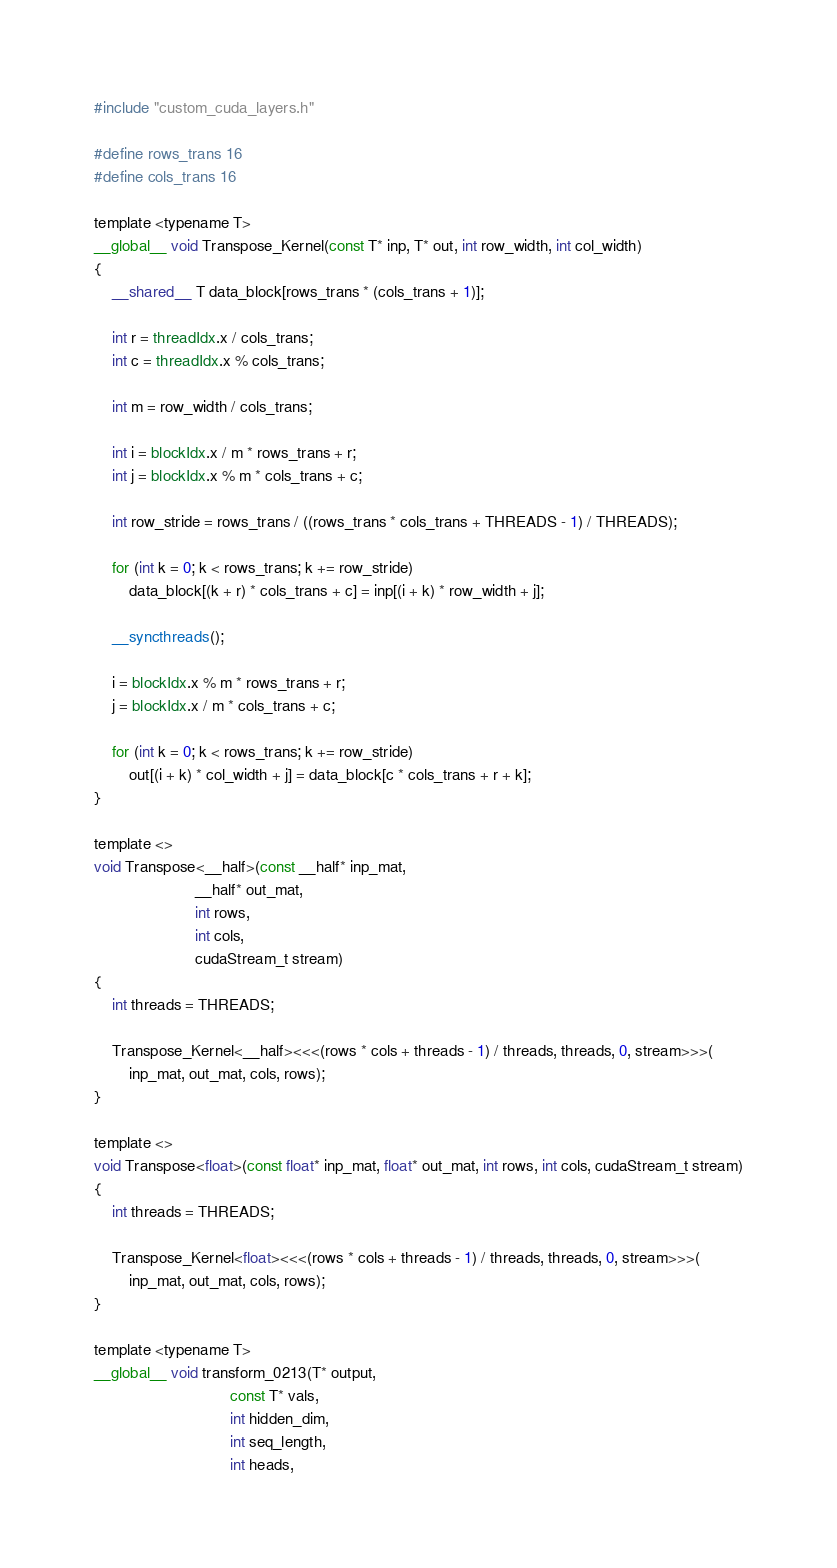<code> <loc_0><loc_0><loc_500><loc_500><_Cuda_>#include "custom_cuda_layers.h"

#define rows_trans 16
#define cols_trans 16

template <typename T>
__global__ void Transpose_Kernel(const T* inp, T* out, int row_width, int col_width)
{
    __shared__ T data_block[rows_trans * (cols_trans + 1)];

    int r = threadIdx.x / cols_trans;
    int c = threadIdx.x % cols_trans;

    int m = row_width / cols_trans;

    int i = blockIdx.x / m * rows_trans + r;
    int j = blockIdx.x % m * cols_trans + c;

    int row_stride = rows_trans / ((rows_trans * cols_trans + THREADS - 1) / THREADS);

    for (int k = 0; k < rows_trans; k += row_stride)
        data_block[(k + r) * cols_trans + c] = inp[(i + k) * row_width + j];

    __syncthreads();

    i = blockIdx.x % m * rows_trans + r;
    j = blockIdx.x / m * cols_trans + c;

    for (int k = 0; k < rows_trans; k += row_stride)
        out[(i + k) * col_width + j] = data_block[c * cols_trans + r + k];
}

template <>
void Transpose<__half>(const __half* inp_mat,
                       __half* out_mat,
                       int rows,
                       int cols,
                       cudaStream_t stream)
{
    int threads = THREADS;

    Transpose_Kernel<__half><<<(rows * cols + threads - 1) / threads, threads, 0, stream>>>(
        inp_mat, out_mat, cols, rows);
}

template <>
void Transpose<float>(const float* inp_mat, float* out_mat, int rows, int cols, cudaStream_t stream)
{
    int threads = THREADS;

    Transpose_Kernel<float><<<(rows * cols + threads - 1) / threads, threads, 0, stream>>>(
        inp_mat, out_mat, cols, rows);
}

template <typename T>
__global__ void transform_0213(T* output,
                               const T* vals,
                               int hidden_dim,
                               int seq_length,
                               int heads,</code> 